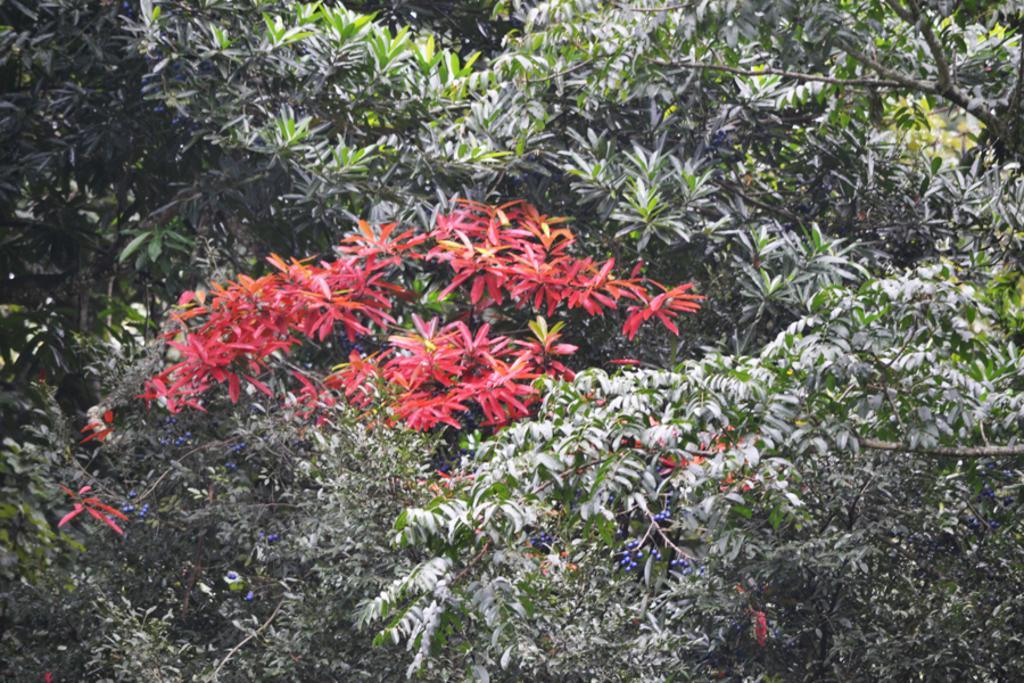In one or two sentences, can you explain what this image depicts? In this picture we can see trees. 